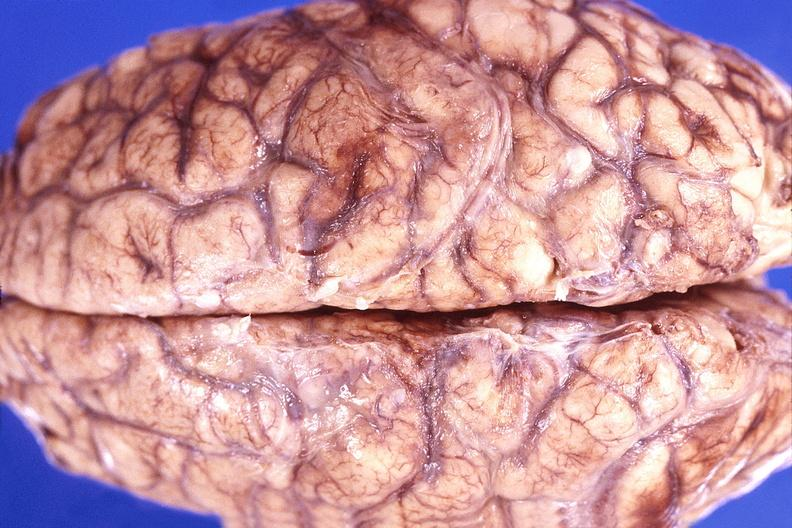does this image show brain abscess?
Answer the question using a single word or phrase. Yes 